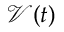<formula> <loc_0><loc_0><loc_500><loc_500>\mathcal { V } ( t )</formula> 